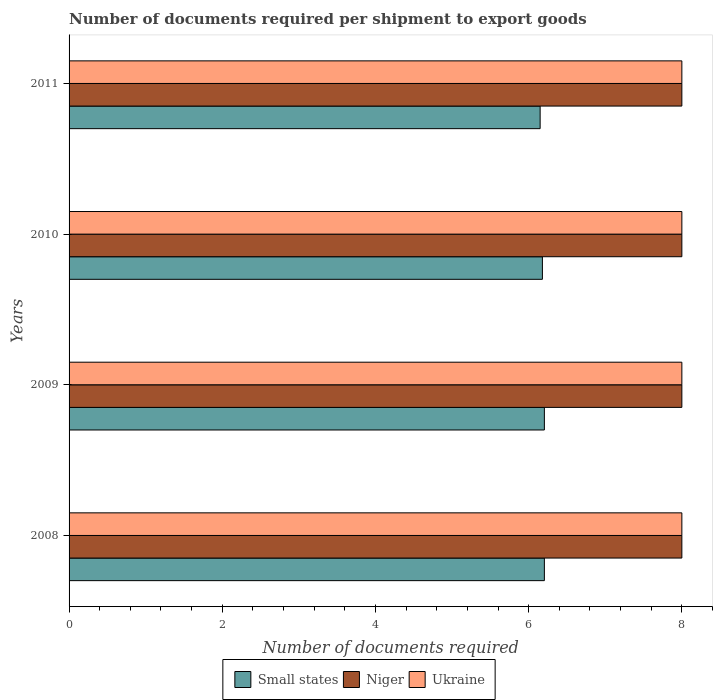In how many cases, is the number of bars for a given year not equal to the number of legend labels?
Give a very brief answer. 0. What is the number of documents required per shipment to export goods in Ukraine in 2011?
Your answer should be compact. 8. Across all years, what is the maximum number of documents required per shipment to export goods in Small states?
Offer a terse response. 6.21. Across all years, what is the minimum number of documents required per shipment to export goods in Small states?
Give a very brief answer. 6.15. What is the total number of documents required per shipment to export goods in Small states in the graph?
Offer a very short reply. 24.74. What is the difference between the number of documents required per shipment to export goods in Small states in 2009 and that in 2010?
Your answer should be very brief. 0.03. What is the difference between the number of documents required per shipment to export goods in Small states in 2010 and the number of documents required per shipment to export goods in Niger in 2008?
Your answer should be very brief. -1.82. What is the average number of documents required per shipment to export goods in Ukraine per year?
Keep it short and to the point. 8. Is the number of documents required per shipment to export goods in Niger in 2008 less than that in 2010?
Provide a short and direct response. No. Is the difference between the number of documents required per shipment to export goods in Niger in 2008 and 2009 greater than the difference between the number of documents required per shipment to export goods in Ukraine in 2008 and 2009?
Give a very brief answer. No. What is the difference between the highest and the second highest number of documents required per shipment to export goods in Ukraine?
Provide a succinct answer. 0. Is the sum of the number of documents required per shipment to export goods in Ukraine in 2008 and 2010 greater than the maximum number of documents required per shipment to export goods in Niger across all years?
Give a very brief answer. Yes. What does the 3rd bar from the top in 2009 represents?
Keep it short and to the point. Small states. What does the 2nd bar from the bottom in 2009 represents?
Your response must be concise. Niger. What is the difference between two consecutive major ticks on the X-axis?
Give a very brief answer. 2. Are the values on the major ticks of X-axis written in scientific E-notation?
Provide a succinct answer. No. Where does the legend appear in the graph?
Provide a succinct answer. Bottom center. What is the title of the graph?
Offer a very short reply. Number of documents required per shipment to export goods. What is the label or title of the X-axis?
Provide a succinct answer. Number of documents required. What is the label or title of the Y-axis?
Offer a terse response. Years. What is the Number of documents required of Small states in 2008?
Give a very brief answer. 6.21. What is the Number of documents required in Niger in 2008?
Your response must be concise. 8. What is the Number of documents required in Small states in 2009?
Provide a short and direct response. 6.21. What is the Number of documents required in Small states in 2010?
Make the answer very short. 6.18. What is the Number of documents required of Niger in 2010?
Offer a very short reply. 8. What is the Number of documents required in Small states in 2011?
Your answer should be compact. 6.15. What is the Number of documents required in Niger in 2011?
Keep it short and to the point. 8. Across all years, what is the maximum Number of documents required of Small states?
Your answer should be compact. 6.21. Across all years, what is the minimum Number of documents required in Small states?
Your answer should be compact. 6.15. Across all years, what is the minimum Number of documents required of Ukraine?
Your answer should be very brief. 8. What is the total Number of documents required in Small states in the graph?
Offer a very short reply. 24.74. What is the difference between the Number of documents required of Ukraine in 2008 and that in 2009?
Offer a terse response. 0. What is the difference between the Number of documents required in Small states in 2008 and that in 2010?
Your response must be concise. 0.03. What is the difference between the Number of documents required in Niger in 2008 and that in 2010?
Ensure brevity in your answer.  0. What is the difference between the Number of documents required in Ukraine in 2008 and that in 2010?
Make the answer very short. 0. What is the difference between the Number of documents required in Small states in 2008 and that in 2011?
Give a very brief answer. 0.06. What is the difference between the Number of documents required of Ukraine in 2008 and that in 2011?
Offer a very short reply. 0. What is the difference between the Number of documents required of Small states in 2009 and that in 2010?
Offer a terse response. 0.03. What is the difference between the Number of documents required of Niger in 2009 and that in 2010?
Your answer should be compact. 0. What is the difference between the Number of documents required of Small states in 2009 and that in 2011?
Provide a succinct answer. 0.06. What is the difference between the Number of documents required of Ukraine in 2009 and that in 2011?
Offer a very short reply. 0. What is the difference between the Number of documents required of Small states in 2010 and that in 2011?
Offer a terse response. 0.03. What is the difference between the Number of documents required in Ukraine in 2010 and that in 2011?
Provide a short and direct response. 0. What is the difference between the Number of documents required of Small states in 2008 and the Number of documents required of Niger in 2009?
Your answer should be compact. -1.79. What is the difference between the Number of documents required of Small states in 2008 and the Number of documents required of Ukraine in 2009?
Give a very brief answer. -1.79. What is the difference between the Number of documents required of Niger in 2008 and the Number of documents required of Ukraine in 2009?
Ensure brevity in your answer.  0. What is the difference between the Number of documents required in Small states in 2008 and the Number of documents required in Niger in 2010?
Give a very brief answer. -1.79. What is the difference between the Number of documents required in Small states in 2008 and the Number of documents required in Ukraine in 2010?
Provide a short and direct response. -1.79. What is the difference between the Number of documents required of Small states in 2008 and the Number of documents required of Niger in 2011?
Your answer should be very brief. -1.79. What is the difference between the Number of documents required of Small states in 2008 and the Number of documents required of Ukraine in 2011?
Keep it short and to the point. -1.79. What is the difference between the Number of documents required in Niger in 2008 and the Number of documents required in Ukraine in 2011?
Offer a very short reply. 0. What is the difference between the Number of documents required in Small states in 2009 and the Number of documents required in Niger in 2010?
Your answer should be very brief. -1.79. What is the difference between the Number of documents required in Small states in 2009 and the Number of documents required in Ukraine in 2010?
Offer a very short reply. -1.79. What is the difference between the Number of documents required of Small states in 2009 and the Number of documents required of Niger in 2011?
Provide a succinct answer. -1.79. What is the difference between the Number of documents required of Small states in 2009 and the Number of documents required of Ukraine in 2011?
Offer a terse response. -1.79. What is the difference between the Number of documents required in Small states in 2010 and the Number of documents required in Niger in 2011?
Keep it short and to the point. -1.82. What is the difference between the Number of documents required in Small states in 2010 and the Number of documents required in Ukraine in 2011?
Provide a short and direct response. -1.82. What is the average Number of documents required in Small states per year?
Keep it short and to the point. 6.18. In the year 2008, what is the difference between the Number of documents required in Small states and Number of documents required in Niger?
Offer a very short reply. -1.79. In the year 2008, what is the difference between the Number of documents required of Small states and Number of documents required of Ukraine?
Give a very brief answer. -1.79. In the year 2008, what is the difference between the Number of documents required in Niger and Number of documents required in Ukraine?
Offer a terse response. 0. In the year 2009, what is the difference between the Number of documents required in Small states and Number of documents required in Niger?
Provide a short and direct response. -1.79. In the year 2009, what is the difference between the Number of documents required in Small states and Number of documents required in Ukraine?
Your answer should be very brief. -1.79. In the year 2010, what is the difference between the Number of documents required of Small states and Number of documents required of Niger?
Give a very brief answer. -1.82. In the year 2010, what is the difference between the Number of documents required of Small states and Number of documents required of Ukraine?
Your answer should be compact. -1.82. In the year 2010, what is the difference between the Number of documents required in Niger and Number of documents required in Ukraine?
Offer a terse response. 0. In the year 2011, what is the difference between the Number of documents required in Small states and Number of documents required in Niger?
Offer a terse response. -1.85. In the year 2011, what is the difference between the Number of documents required in Small states and Number of documents required in Ukraine?
Provide a short and direct response. -1.85. In the year 2011, what is the difference between the Number of documents required in Niger and Number of documents required in Ukraine?
Keep it short and to the point. 0. What is the ratio of the Number of documents required of Niger in 2008 to that in 2009?
Provide a short and direct response. 1. What is the ratio of the Number of documents required in Small states in 2008 to that in 2010?
Keep it short and to the point. 1. What is the ratio of the Number of documents required in Ukraine in 2008 to that in 2010?
Provide a short and direct response. 1. What is the ratio of the Number of documents required of Ukraine in 2008 to that in 2011?
Keep it short and to the point. 1. What is the ratio of the Number of documents required in Small states in 2009 to that in 2010?
Your answer should be very brief. 1. What is the difference between the highest and the second highest Number of documents required of Small states?
Keep it short and to the point. 0. What is the difference between the highest and the lowest Number of documents required in Small states?
Your response must be concise. 0.06. What is the difference between the highest and the lowest Number of documents required of Niger?
Provide a succinct answer. 0. 